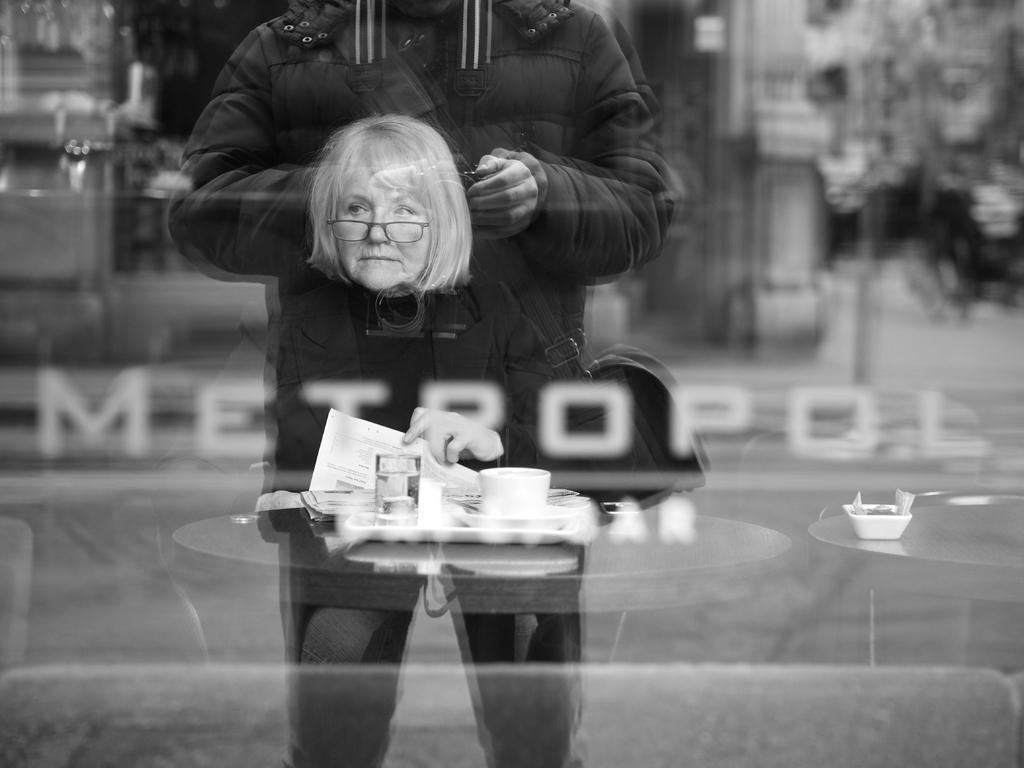Can you describe this image briefly? In the center of this picture we can see the head of a person and a hand of a person holding a paper and there are some objects placed on the top of the table and we can see a person standing on the ground. The background of the image is very blurry. In the center there is a text on the image. 